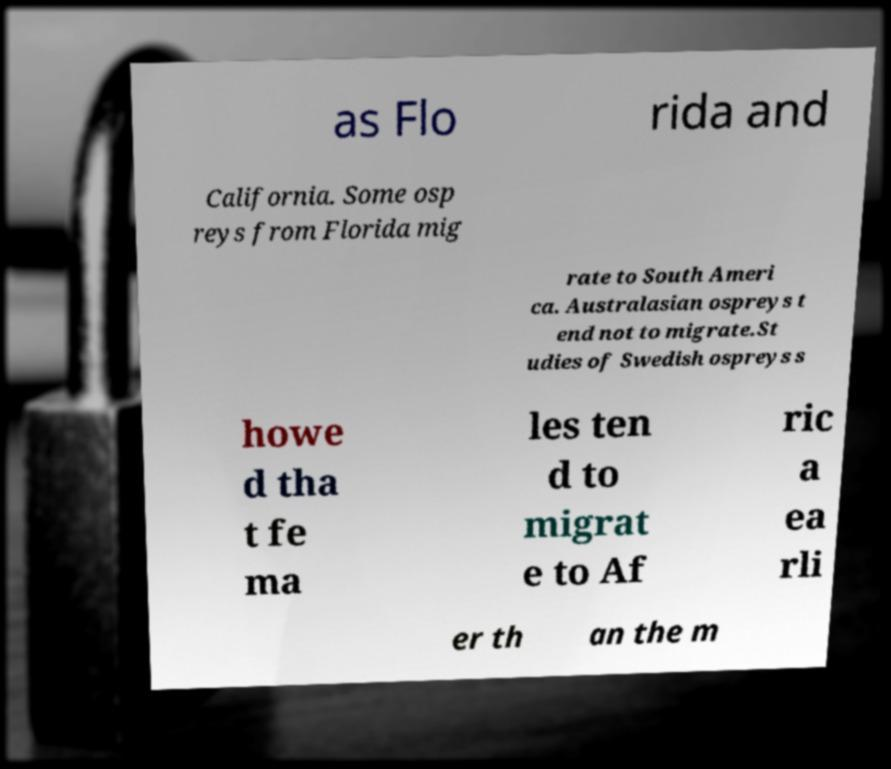For documentation purposes, I need the text within this image transcribed. Could you provide that? as Flo rida and California. Some osp reys from Florida mig rate to South Ameri ca. Australasian ospreys t end not to migrate.St udies of Swedish ospreys s howe d tha t fe ma les ten d to migrat e to Af ric a ea rli er th an the m 